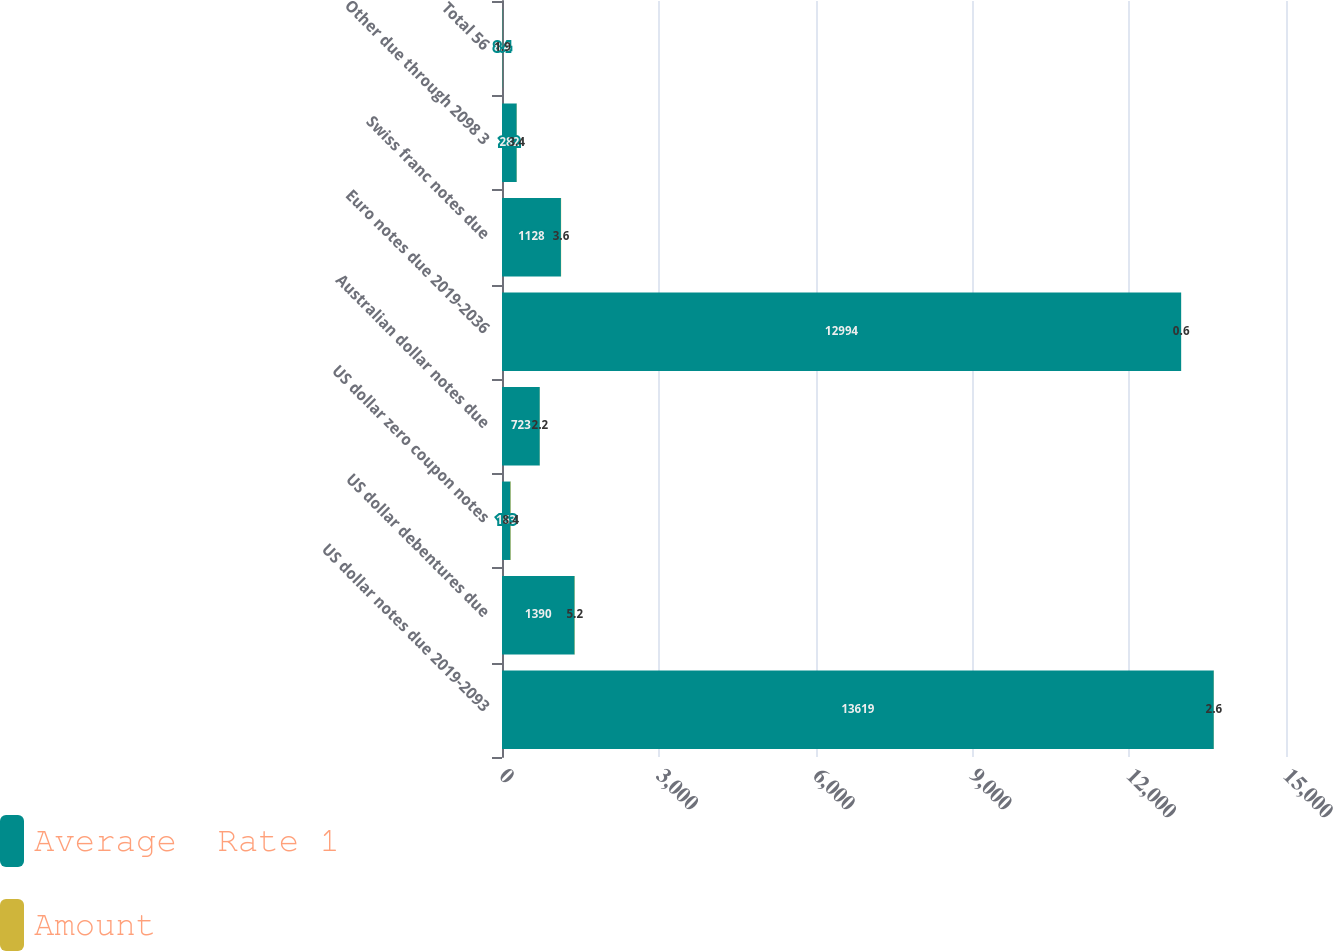<chart> <loc_0><loc_0><loc_500><loc_500><stacked_bar_chart><ecel><fcel>US dollar notes due 2019-2093<fcel>US dollar debentures due<fcel>US dollar zero coupon notes<fcel>Australian dollar notes due<fcel>Euro notes due 2019-2036<fcel>Swiss franc notes due<fcel>Other due through 2098 3<fcel>Total 56<nl><fcel>Average  Rate 1<fcel>13619<fcel>1390<fcel>163<fcel>723<fcel>12994<fcel>1128<fcel>282<fcel>8.4<nl><fcel>Amount<fcel>2.6<fcel>5.2<fcel>8.4<fcel>2.2<fcel>0.6<fcel>3.6<fcel>3.4<fcel>1.9<nl></chart> 